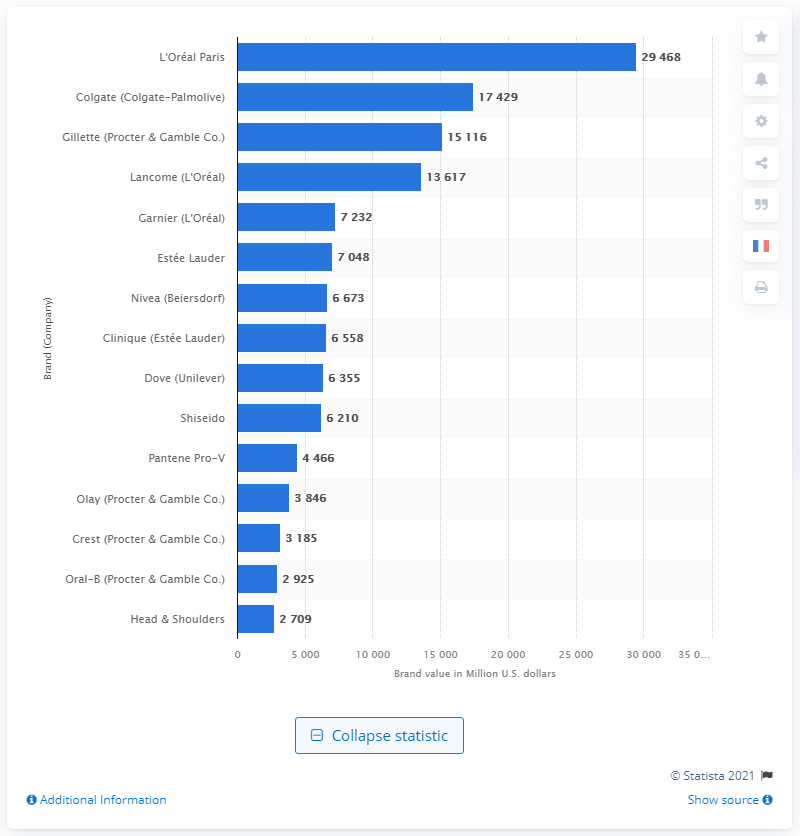Indicate a few pertinent items in this graphic. According to the data provided, the value of the Crest brand in dollars in 2020 was 3,185. 